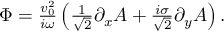<formula> <loc_0><loc_0><loc_500><loc_500>\begin{array} { r } { \Phi = \frac { v _ { 0 } ^ { 2 } } { i \omega } \left ( \frac { 1 } { \sqrt { 2 } } \partial _ { x } A + \frac { i \sigma } { \sqrt { 2 } } \partial _ { y } A \right ) . } \end{array}</formula> 